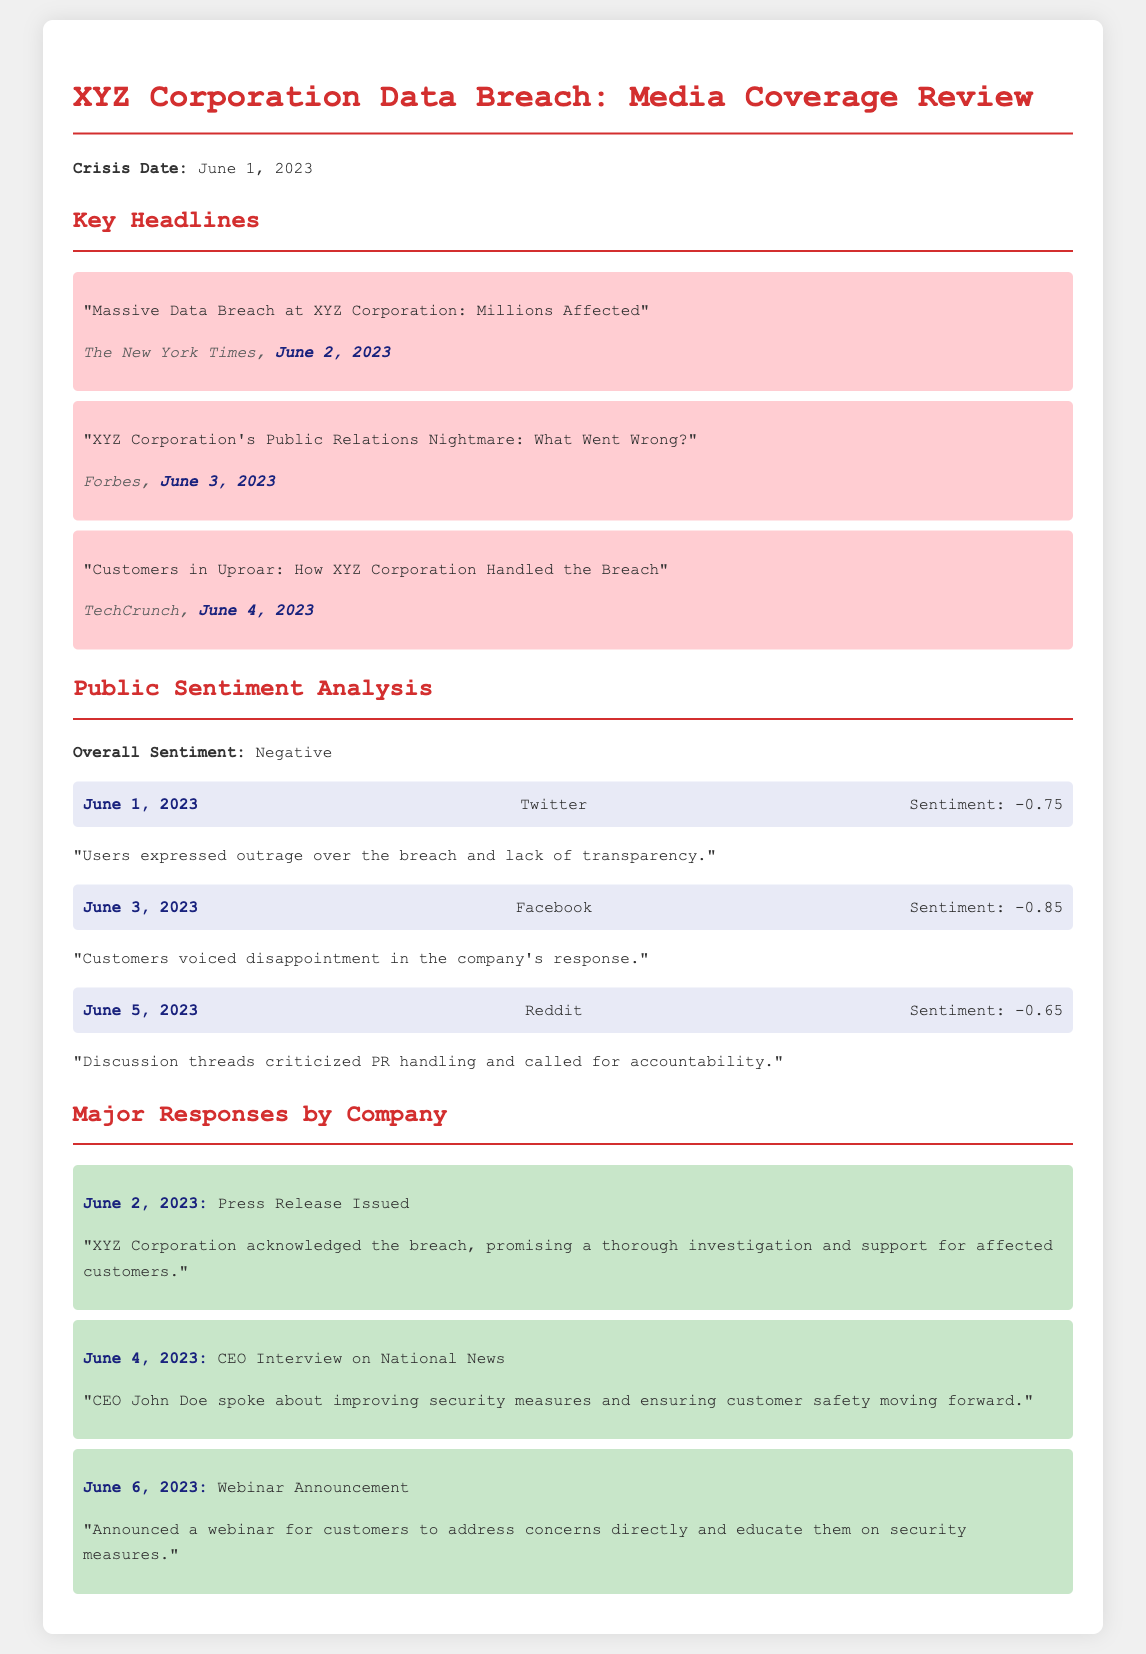What was the date of the crisis? The crisis occurred on June 1, 2023, as stated in the document.
Answer: June 1, 2023 Which publication reported the data breach on June 2, 2023? The New York Times reported the data breach on June 2, 2023, as outlined in the headlines section.
Answer: The New York Times What was the overall public sentiment during the crisis? The document indicates that the overall sentiment was negative, summarizing the public's reaction to the incident.
Answer: Negative How much negative sentiment was recorded on Twitter on June 1, 2023? The Twitter sentiment score on June 1, 2023, was -0.75, as reported in the sentiment analysis section.
Answer: -0.75 What was one of the major responses issued by the company on June 2, 2023? On June 2, 2023, the company issued a press release acknowledging the breach, as detailed in the responses section.
Answer: Press Release Issued What was discussed in the CEO's interview on June 4, 2023? The CEO spoke about improving security measures and customer safety during the interview, as mentioned in the major responses.
Answer: Improving security measures What was the sentiment score on Facebook on June 3, 2023? The sentiment score recorded on Facebook on June 3, 2023, was -0.85, highlighted in the document.
Answer: -0.85 What was announced on June 6, 2023, regarding customer concerns? A webinar was announced on June 6, 2023, to address customer concerns directly, stated in the major responses section.
Answer: Webinar Announcement What was one criticism mentioned in Reddit discussions? Discussion threads criticized PR handling and called for accountability, as referenced in the public sentiment analysis.
Answer: Criticized PR handling 